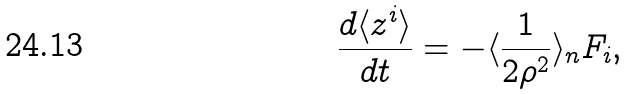<formula> <loc_0><loc_0><loc_500><loc_500>\frac { d \langle z ^ { i } \rangle } { d t } = - \langle \frac { 1 } { 2 \rho ^ { 2 } } \rangle _ { n } F _ { i } ,</formula> 